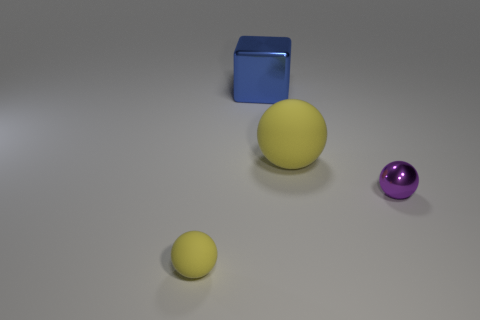Add 1 tiny red matte objects. How many objects exist? 5 Subtract all spheres. How many objects are left? 1 Subtract 0 green balls. How many objects are left? 4 Subtract all small brown rubber balls. Subtract all big blue cubes. How many objects are left? 3 Add 1 metallic cubes. How many metallic cubes are left? 2 Add 1 big yellow spheres. How many big yellow spheres exist? 2 